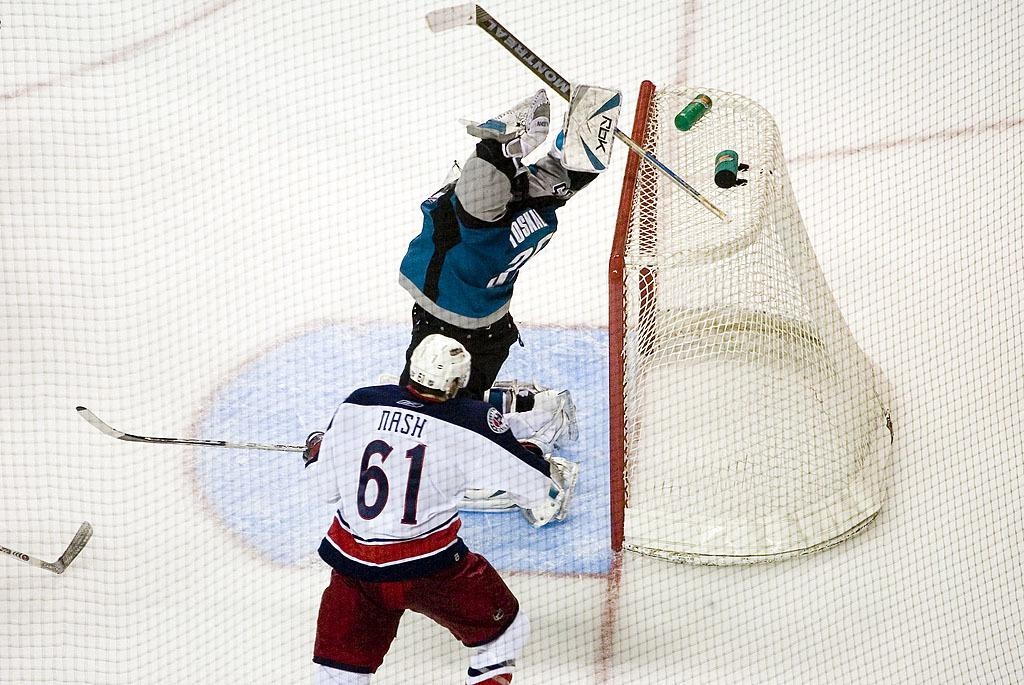What are the two people in the image doing? The two people in the image are playing. What can be seen on the right side of the image? There is a goal post on the right side of the image. How many cats are visible in the image? There are no cats present in the image. What type of agreement is being made between the two people in the image? There is no indication in the image that the two people are making any agreement. 